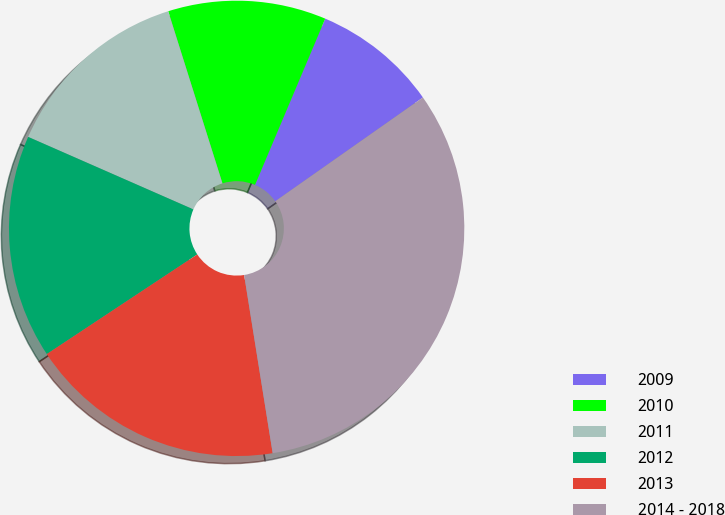Convert chart to OTSL. <chart><loc_0><loc_0><loc_500><loc_500><pie_chart><fcel>2009<fcel>2010<fcel>2011<fcel>2012<fcel>2013<fcel>2014 - 2018<nl><fcel>8.89%<fcel>11.22%<fcel>13.56%<fcel>15.89%<fcel>18.22%<fcel>32.22%<nl></chart> 